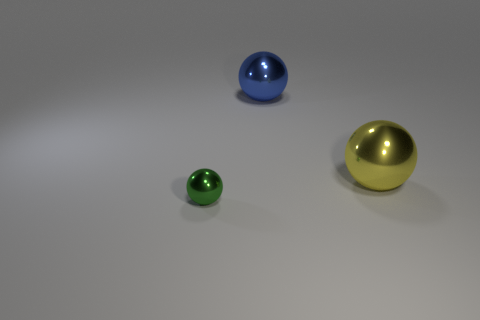Is the size of the yellow thing the same as the metallic ball behind the yellow ball?
Your answer should be very brief. Yes. There is a thing that is on the right side of the tiny green metallic object and in front of the blue metal thing; how big is it?
Provide a short and direct response. Large. Are there any tiny green spheres that have the same material as the blue ball?
Your response must be concise. Yes. What is the shape of the big yellow object?
Provide a succinct answer. Sphere. Does the green metal thing have the same size as the yellow metal ball?
Offer a terse response. No. How many other objects are there of the same shape as the tiny green metal object?
Give a very brief answer. 2. What shape is the big metal thing on the left side of the big yellow ball?
Give a very brief answer. Sphere. There is a object that is to the right of the large blue metal sphere; is it the same shape as the green thing that is in front of the blue sphere?
Provide a succinct answer. Yes. Are there the same number of big yellow objects that are to the left of the large blue object and small green metal cylinders?
Provide a succinct answer. Yes. Are there any other things that have the same size as the green metal thing?
Make the answer very short. No. 